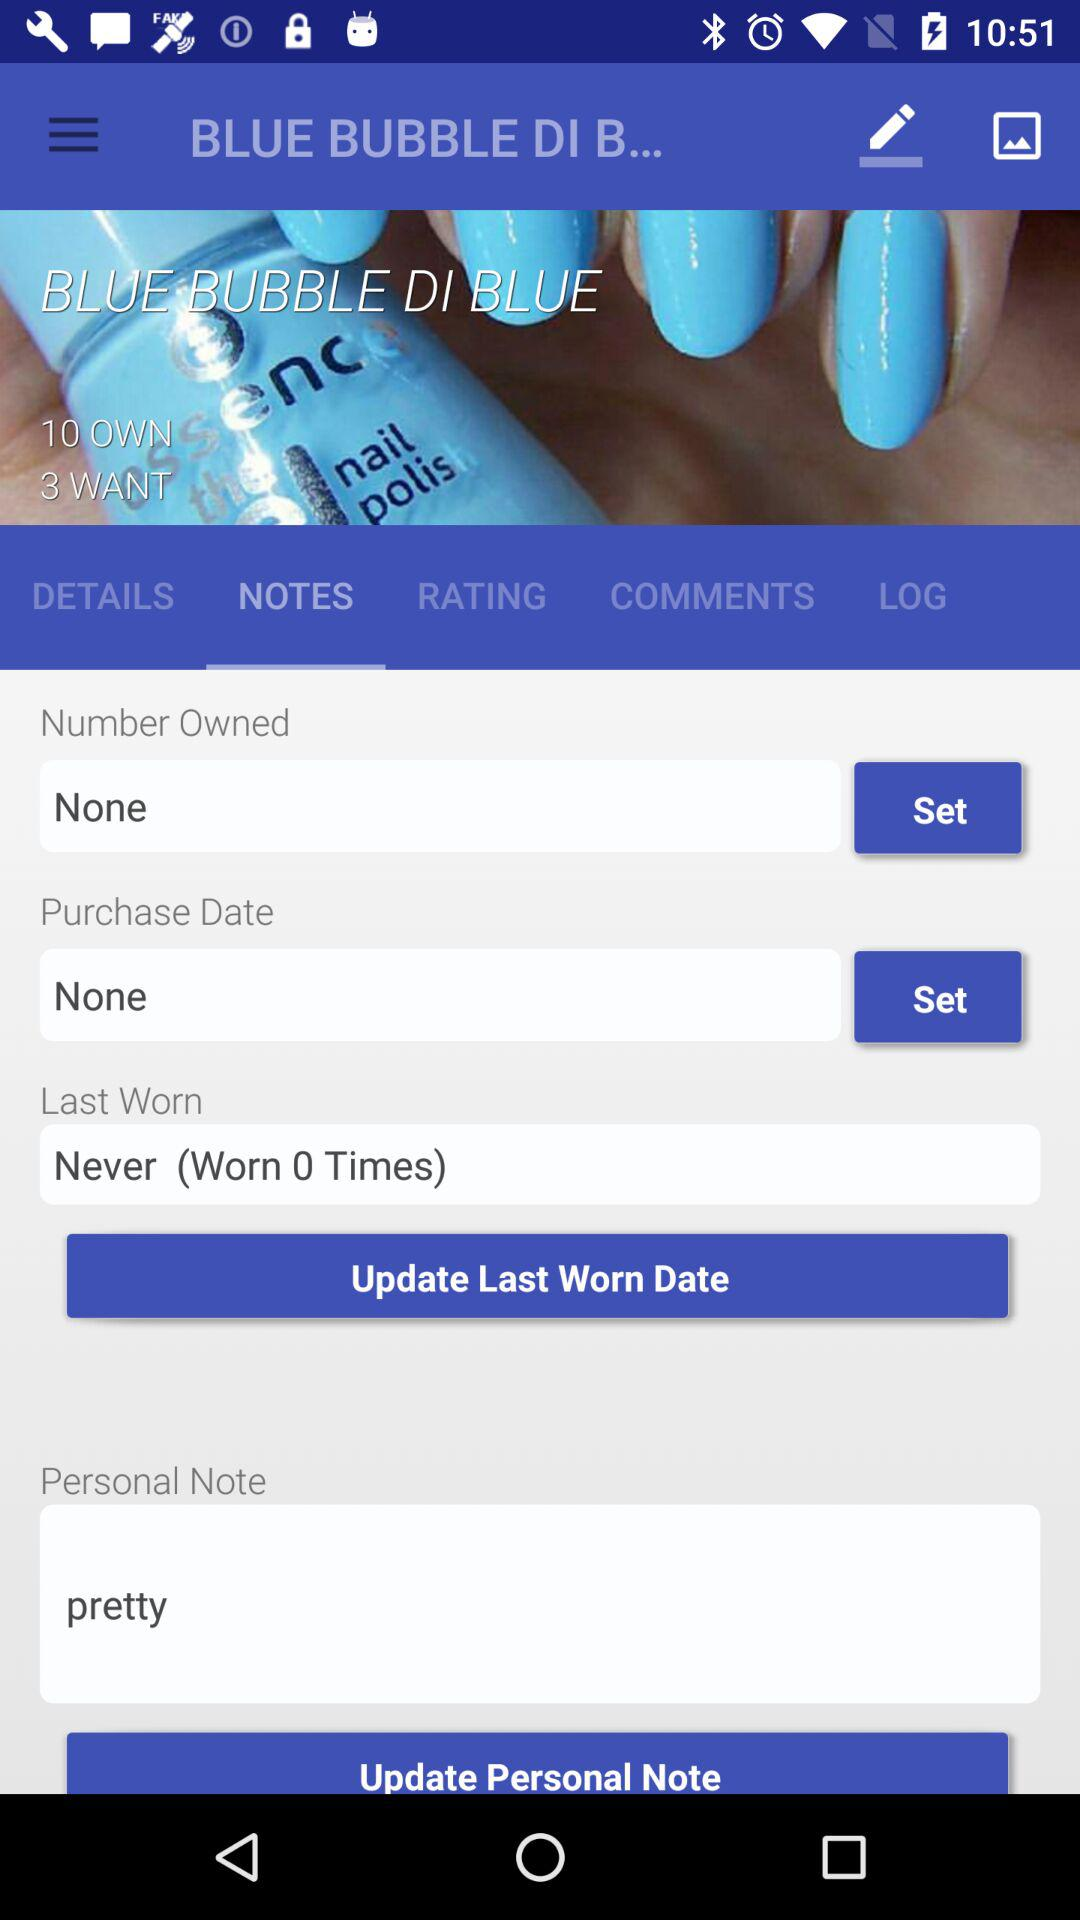How many people own the item and how many people want the item? The number of people who own the item is 10 and the number of people who want the item is 3. 